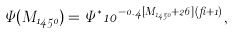<formula> <loc_0><loc_0><loc_500><loc_500>\Psi ( M _ { 1 4 5 0 } ) = \Psi ^ { * } 1 0 ^ { - 0 . 4 [ M _ { 1 4 5 0 } + 2 6 ] ( \beta + 1 ) } ,</formula> 